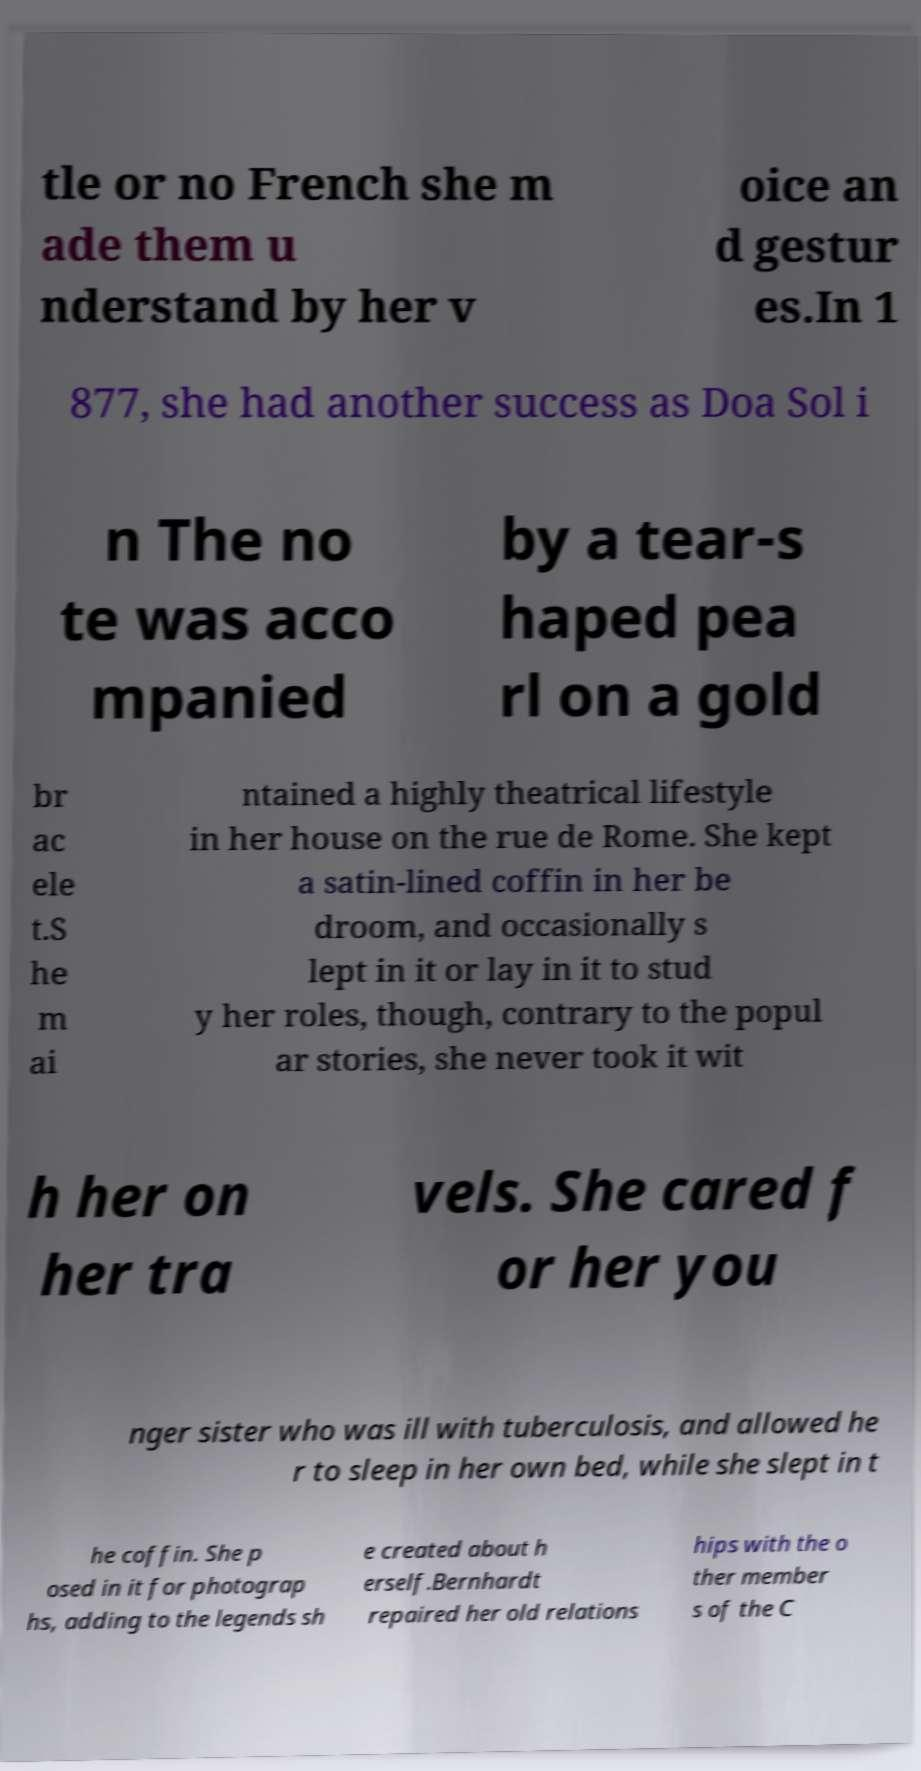I need the written content from this picture converted into text. Can you do that? tle or no French she m ade them u nderstand by her v oice an d gestur es.In 1 877, she had another success as Doa Sol i n The no te was acco mpanied by a tear-s haped pea rl on a gold br ac ele t.S he m ai ntained a highly theatrical lifestyle in her house on the rue de Rome. She kept a satin-lined coffin in her be droom, and occasionally s lept in it or lay in it to stud y her roles, though, contrary to the popul ar stories, she never took it wit h her on her tra vels. She cared f or her you nger sister who was ill with tuberculosis, and allowed he r to sleep in her own bed, while she slept in t he coffin. She p osed in it for photograp hs, adding to the legends sh e created about h erself.Bernhardt repaired her old relations hips with the o ther member s of the C 